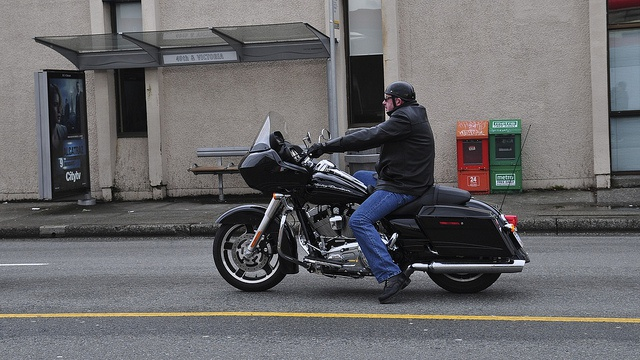Describe the objects in this image and their specific colors. I can see motorcycle in darkgray, black, gray, and lavender tones, people in darkgray, black, navy, gray, and blue tones, and bench in darkgray, gray, and black tones in this image. 